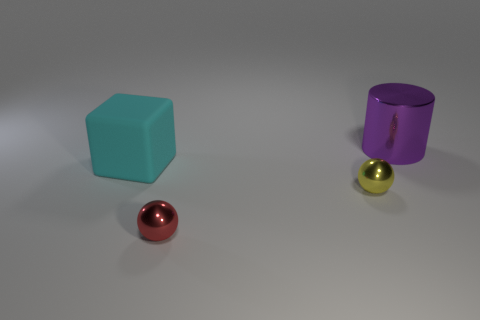Add 1 large cylinders. How many objects exist? 5 Subtract 1 cylinders. How many cylinders are left? 0 Subtract all yellow spheres. How many spheres are left? 1 Subtract all blocks. How many objects are left? 3 Add 3 tiny balls. How many tiny balls are left? 5 Add 2 brown rubber balls. How many brown rubber balls exist? 2 Subtract 0 yellow cylinders. How many objects are left? 4 Subtract all blue spheres. Subtract all cyan cubes. How many spheres are left? 2 Subtract all yellow shiny cylinders. Subtract all large purple shiny objects. How many objects are left? 3 